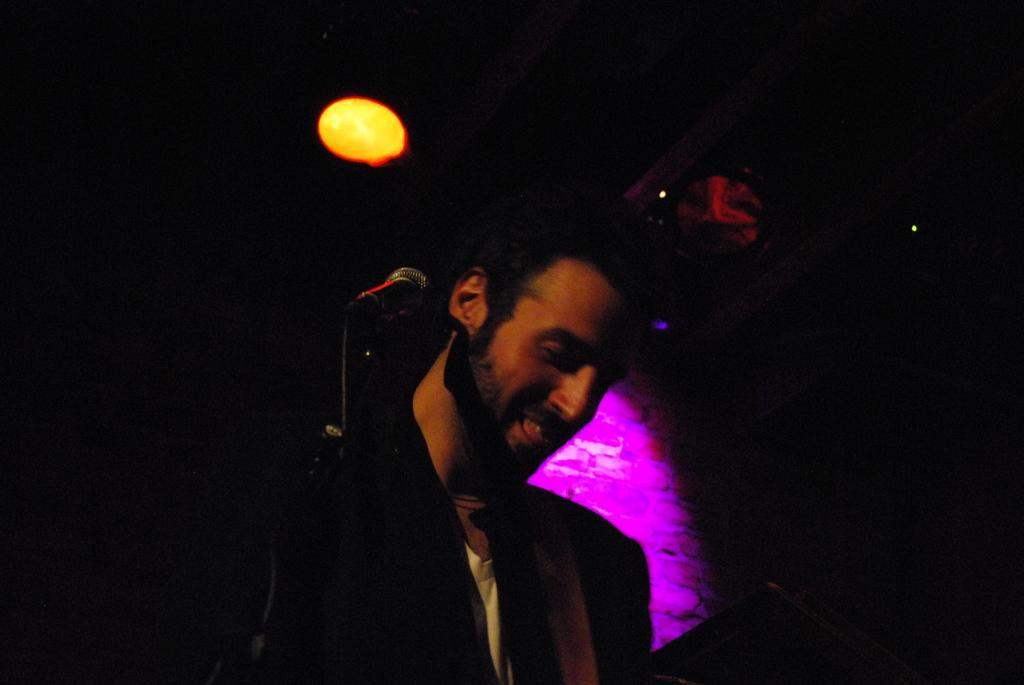Describe this image in one or two sentences. In the center of the image, there is a man standing and there is a mic stand. 